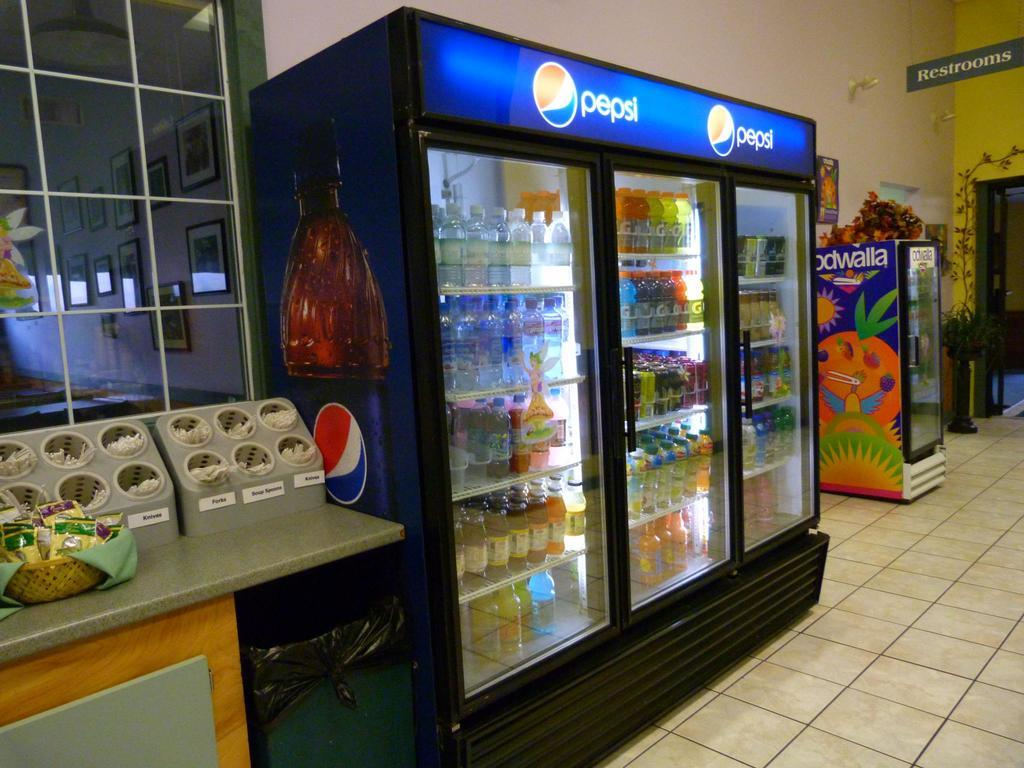<image>
Offer a succinct explanation of the picture presented. Various beverages are displayed in a cooler with the Pepsi brand on top. 